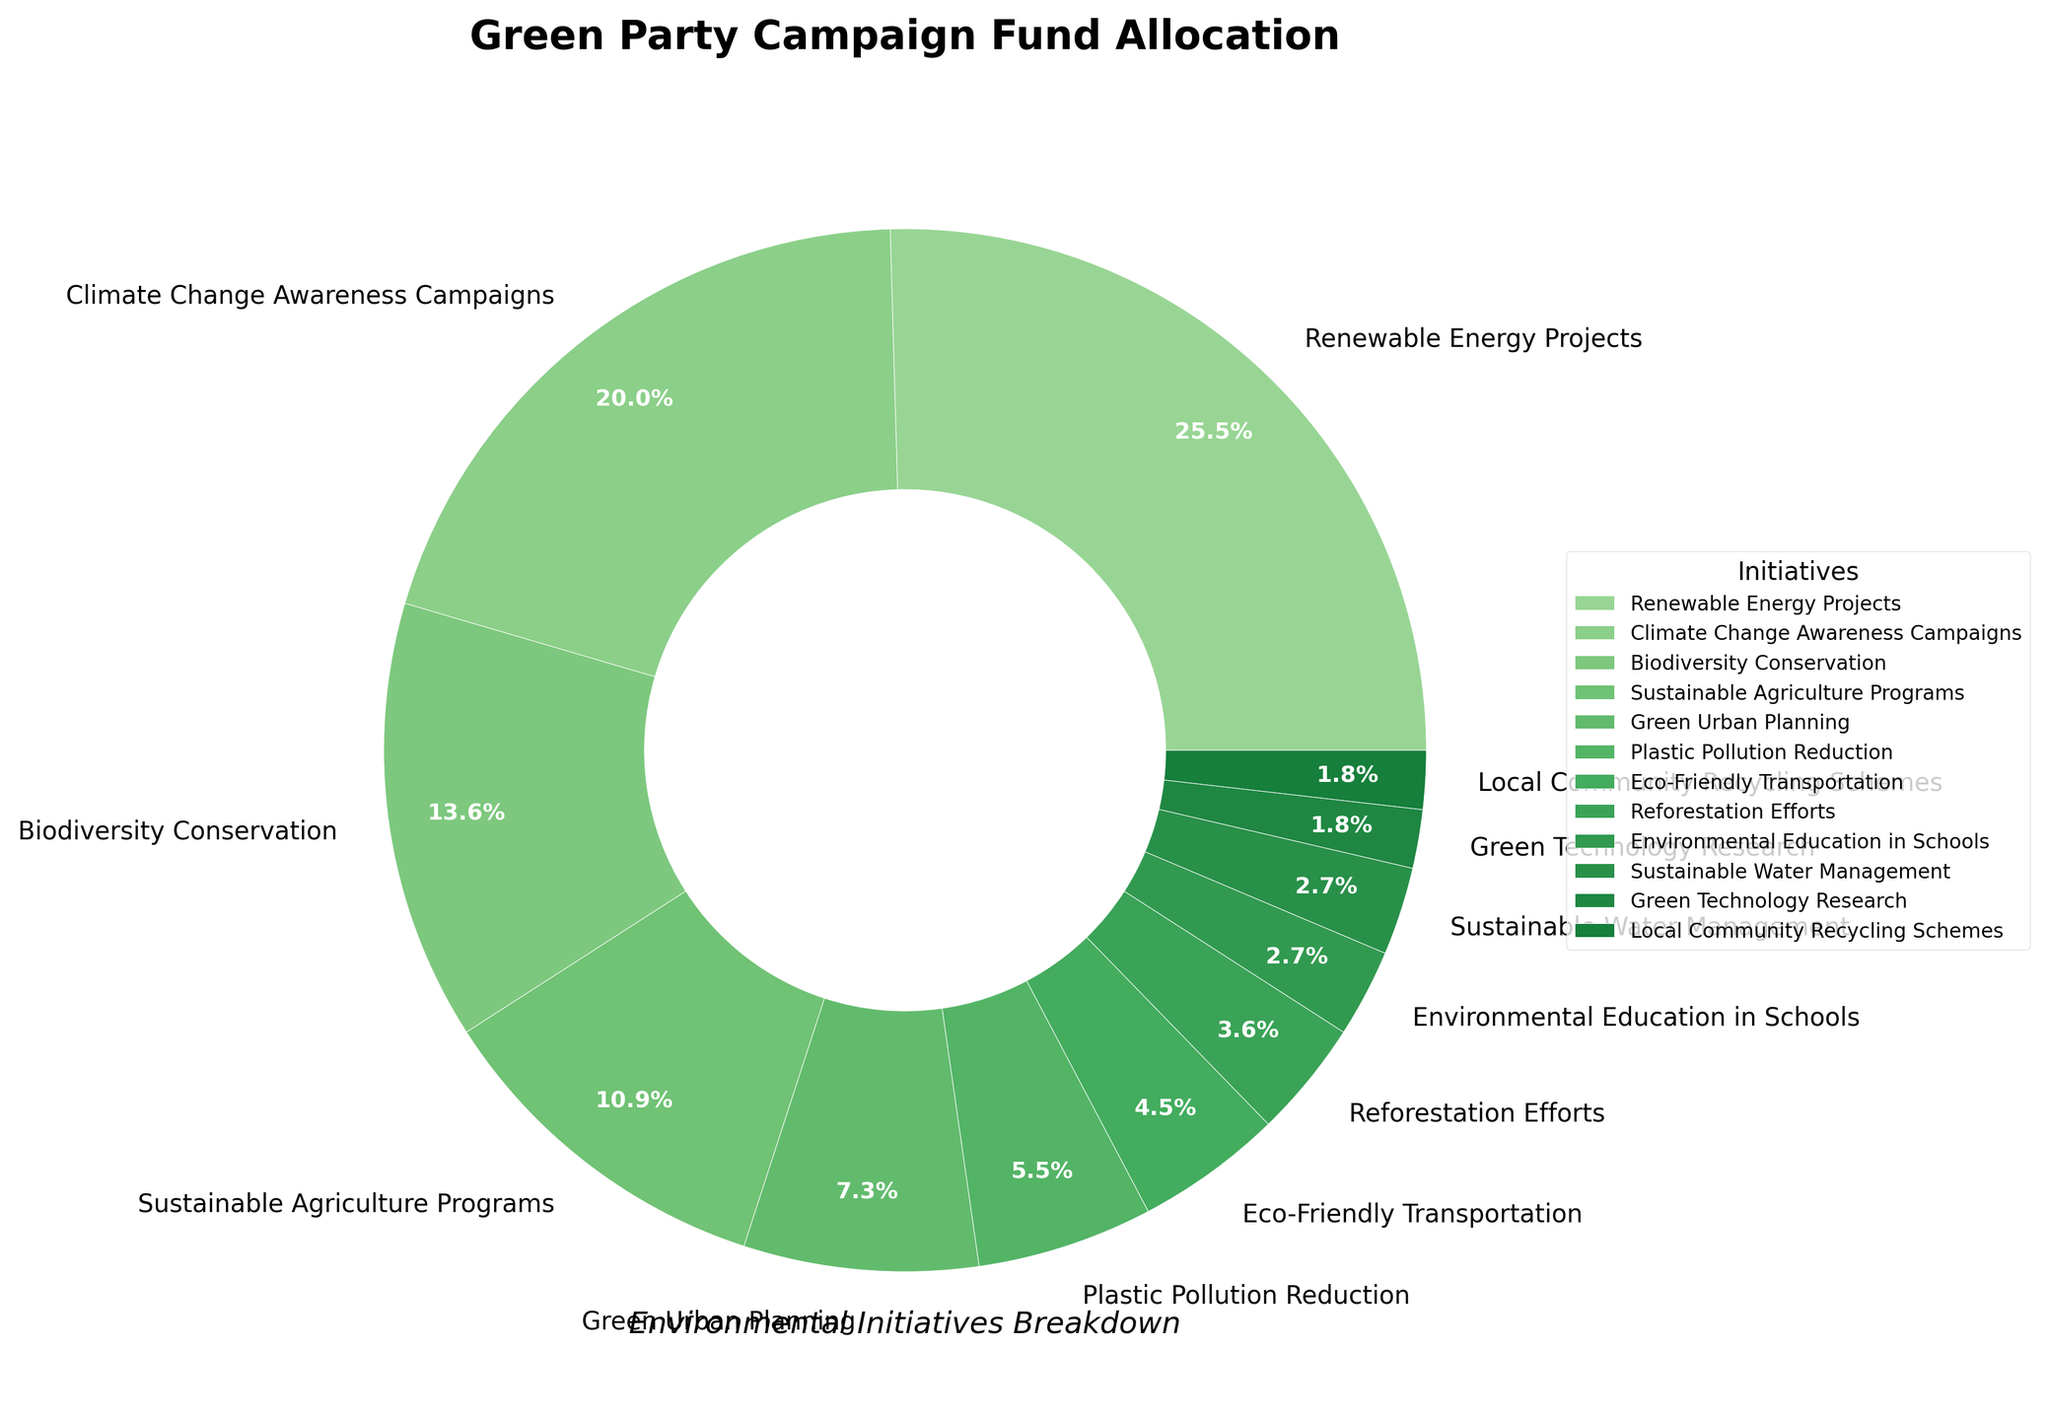Which initiative receives the highest percentage of the Green Party campaign funds? The pie chart shows that "Renewable Energy Projects" receives the largest slice of the pie. By glancing at the chart's segments, it's clear that this initiative has the highest allocation.
Answer: Renewable Energy Projects How much more funding percentage do Climate Change Awareness Campaigns receive compared to Local Community Recycling Schemes? "Climate Change Awareness Campaigns" have a 22% allocation, while "Local Community Recycling Schemes" have 2%. Subtracting the latter from the former (22% - 2%) gives us the difference.
Answer: 20% Which initiative has the smallest allocation of campaign funds? By looking at the smallest segment of the pie chart, we can see that "Local Community Recycling Schemes" and "Green Technology Research" have the smallest allocation, each with 2%.
Answer: Green Technology Research or Local Community Recycling Schemes What is the combined percentage of the funds allocated to Biodiversity Conservation, Sustainable Agriculture Programs, and Sustainable Water Management? Adding the percentages for "Biodiversity Conservation" (15%), "Sustainable Agriculture Programs" (12%), and "Sustainable Water Management" (3%) gives us 15% + 12% + 3% = 30%.
Answer: 30% Which initiative has a higher percentage allocation: Eco-Friendly Transportation or Green Urban Planning? By comparing the two segments, "Green Urban Planning" has an 8% allocation while "Eco-Friendly Transportation" has 5%. Thus, "Green Urban Planning" has a higher percentage allocation.
Answer: Green Urban Planning How does the funding percentage for Plastic Pollution Reduction compare to that for Reforestation Efforts? By referencing the pie chart, "Plastic Pollution Reduction" is allocated 6%, and "Reforestation Efforts" is allocated 4%. Comparing these, Plastic Pollution Reduction has a higher percentage.
Answer: Plastic Pollution Reduction If the total funding is £1,000,000, how much money is allocated to Environmental Education in Schools? Environmental Education in Schools is allocated 3%. Calculating 3% of £1,000,000: 0.03 * 1,000,000 = £30,000.
Answer: £30,000 Are there more initiatives with an allocation greater than 10% or fewer than 5%? The initiatives greater than 10% are Renewable Energy Projects (28%), Climate Change Awareness Campaigns (22%), Biodiversity Conservation (15%), and Sustainable Agriculture Programs (12%), totaling 4 initiatives. Those allocated fewer than 5% are Reforestation Efforts (4%), Environmental Education in Schools (3%), Sustainable Water Management (3%), Green Technology Research (2%), and Local Community Recycling Schemes (2%), totaling 5 initiatives.
Answer: Fewer than 5% What percentage of the funds goes toward initiatives with more than 20% each? The only initiatives with more than 20% each are "Renewable Energy Projects" (28%) and "Climate Change Awareness Campaigns" (22%). Their combined percentage is 28% + 22% = 50%.
Answer: 50% 